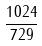<formula> <loc_0><loc_0><loc_500><loc_500>\frac { 1 0 2 4 } { 7 2 9 }</formula> 